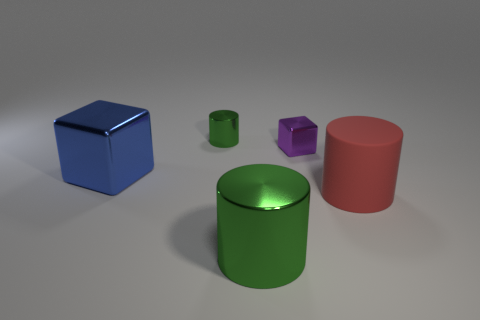Are there any other things that are the same material as the red cylinder?
Your answer should be compact. No. What number of other objects are the same size as the blue thing?
Your answer should be compact. 2. What is the material of the other green thing that is the same shape as the small green metallic object?
Offer a very short reply. Metal. Is the number of green objects that are in front of the tiny purple metallic thing greater than the number of large blue spheres?
Your response must be concise. Yes. Is there any other thing that is the same color as the big matte object?
Offer a very short reply. No. The purple object that is made of the same material as the big green cylinder is what shape?
Provide a succinct answer. Cube. Is the material of the large cylinder that is in front of the red rubber thing the same as the big red thing?
Provide a succinct answer. No. There is a small metallic thing that is the same color as the large shiny cylinder; what is its shape?
Ensure brevity in your answer.  Cylinder. There is a small metal object that is behind the tiny cube; does it have the same color as the metallic thing that is in front of the blue object?
Ensure brevity in your answer.  Yes. What number of large things are to the left of the big green shiny cylinder and right of the purple thing?
Provide a short and direct response. 0. 